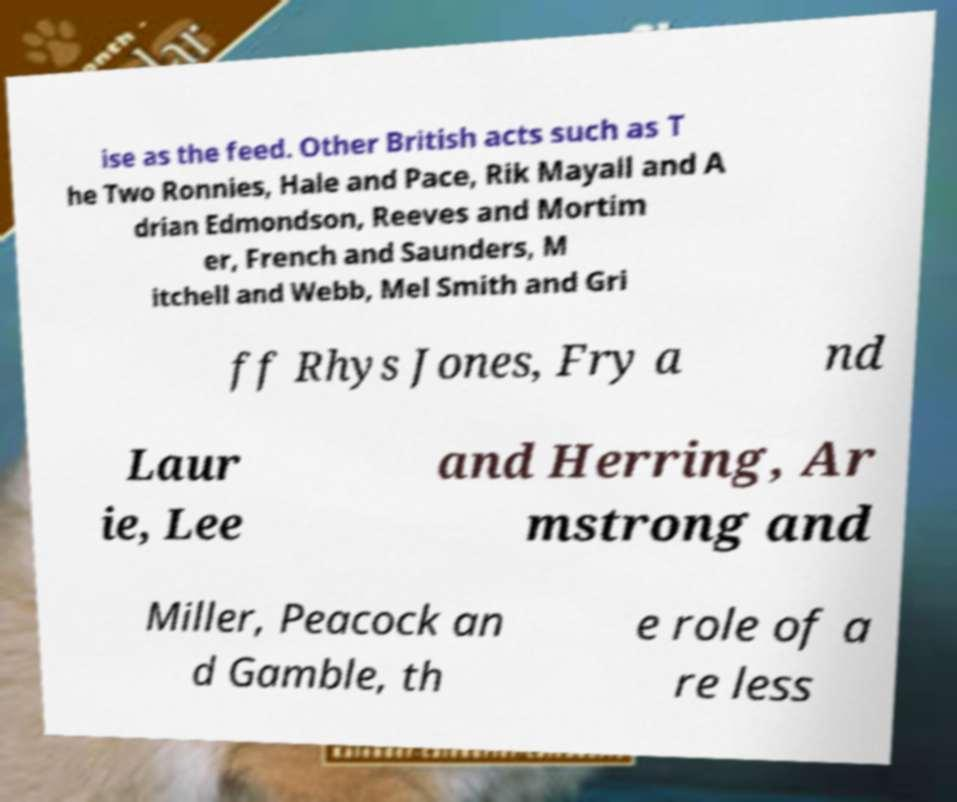Please identify and transcribe the text found in this image. ise as the feed. Other British acts such as T he Two Ronnies, Hale and Pace, Rik Mayall and A drian Edmondson, Reeves and Mortim er, French and Saunders, M itchell and Webb, Mel Smith and Gri ff Rhys Jones, Fry a nd Laur ie, Lee and Herring, Ar mstrong and Miller, Peacock an d Gamble, th e role of a re less 